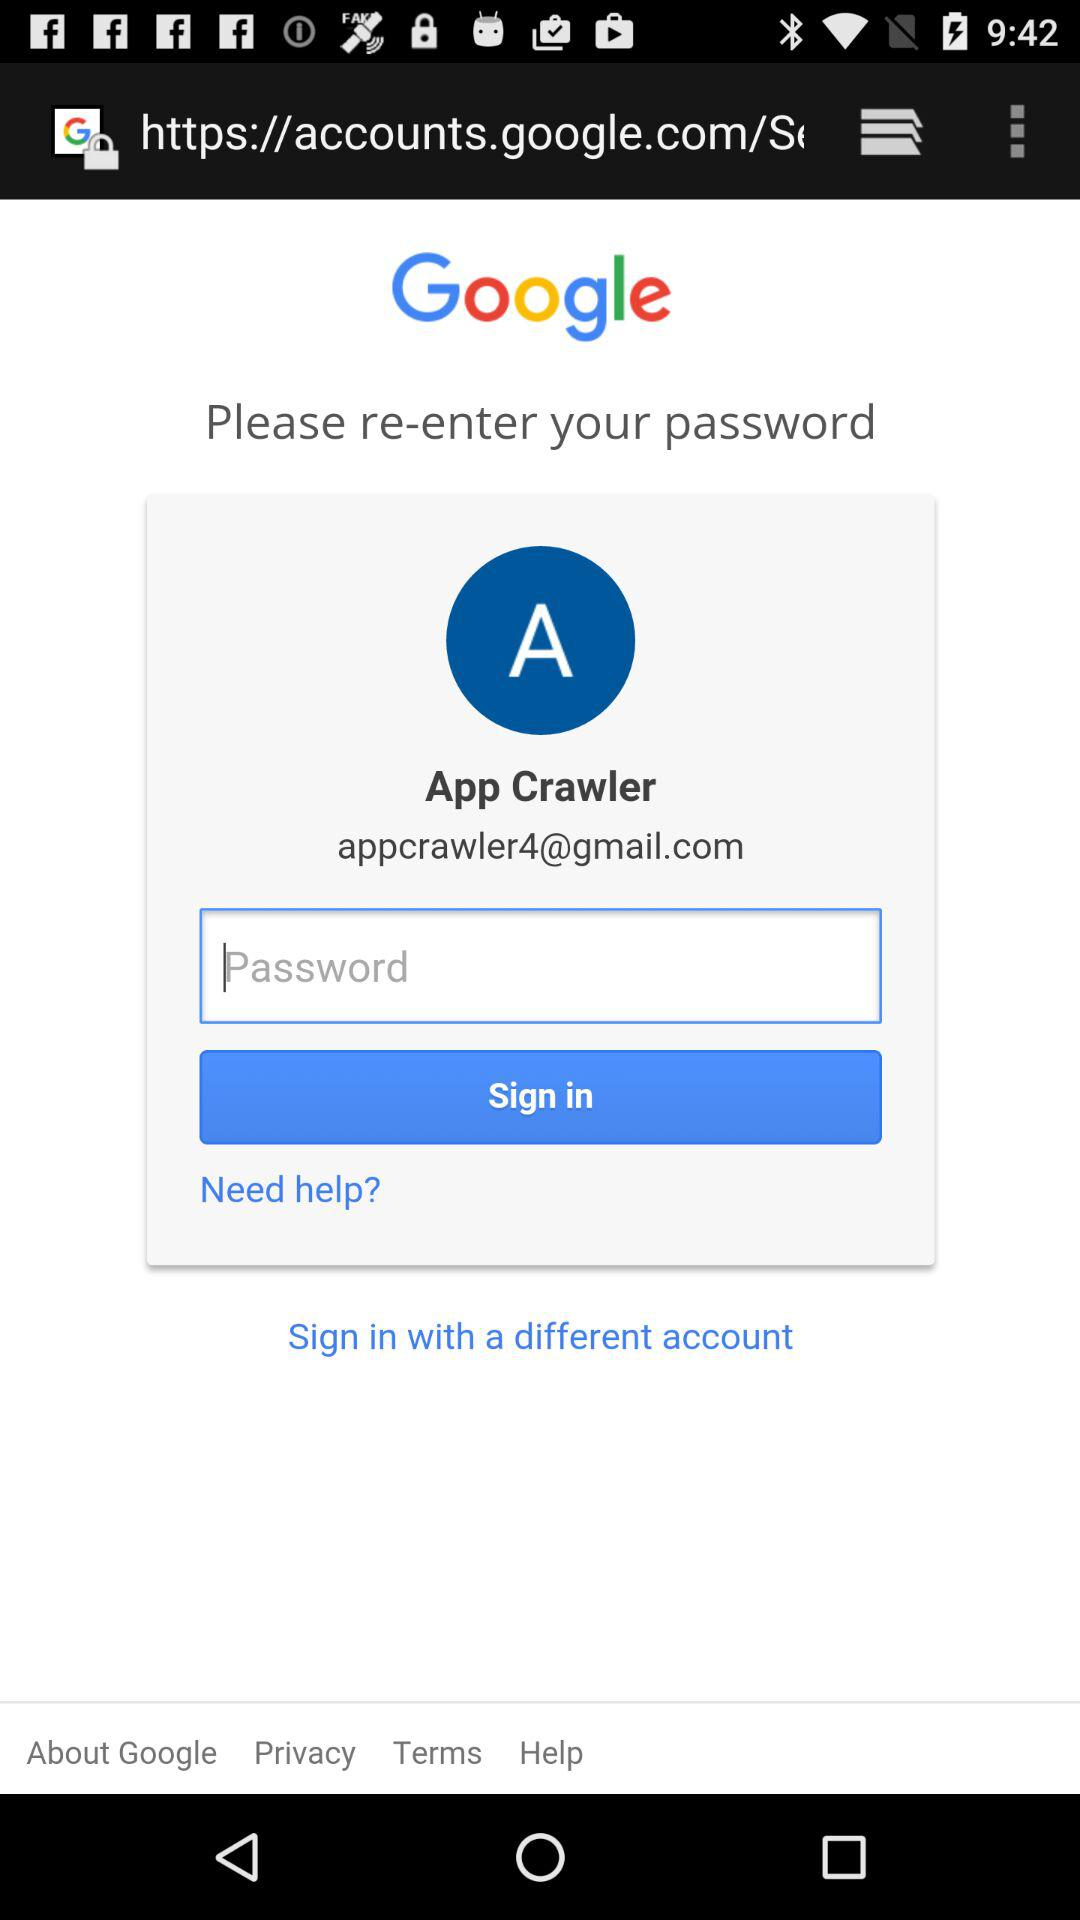What is the email address of the user? The email address is appcrawler4@gmail.com. 